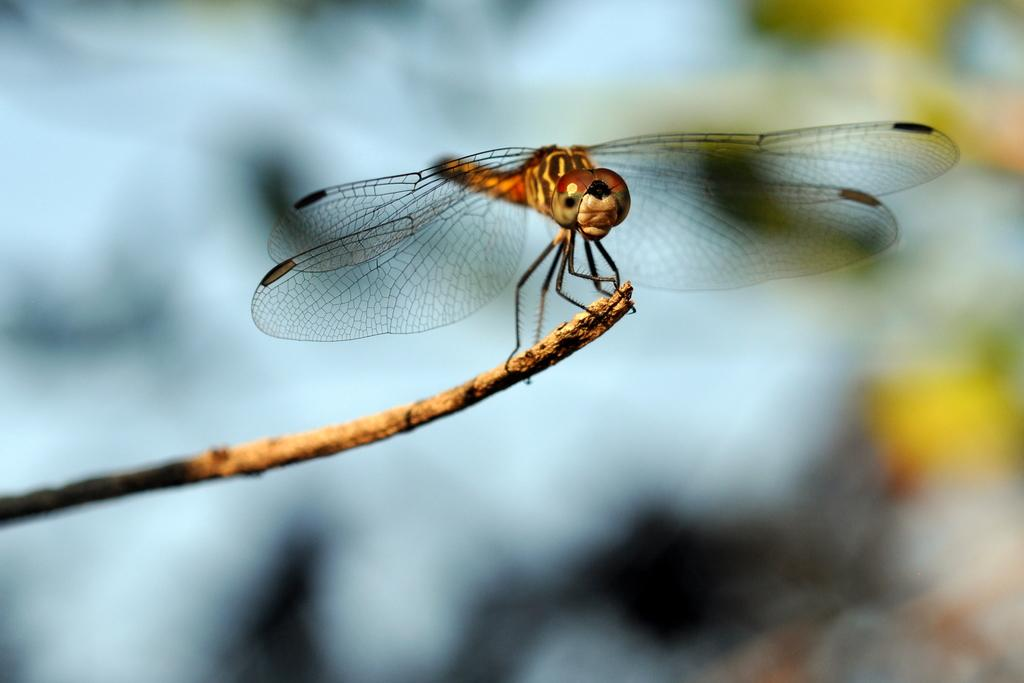What type of insect is in the image? There is a dragonfly in the image. Where is the dragonfly located? The dragonfly is on a dry stem. Can you describe the background of the image? The background of the image is blurry. What type of education is being provided in the image? There is no indication of education in the image; it features a dragonfly on a dry stem with a blurry background. 